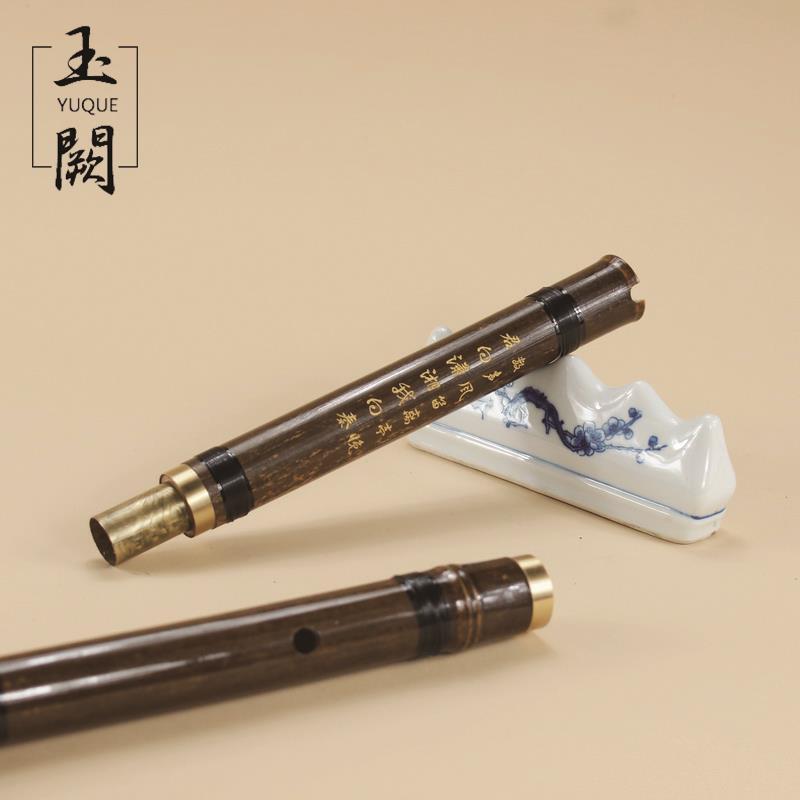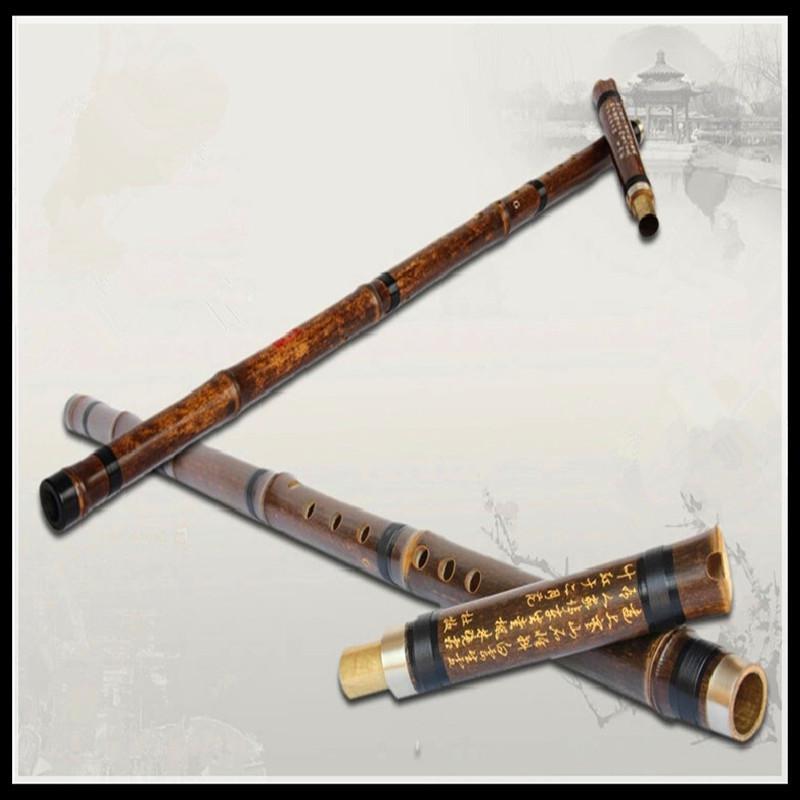The first image is the image on the left, the second image is the image on the right. Given the left and right images, does the statement "There are exactly two flutes." hold true? Answer yes or no. No. The first image is the image on the left, the second image is the image on the right. Examine the images to the left and right. Is the description "There are two instruments." accurate? Answer yes or no. No. 